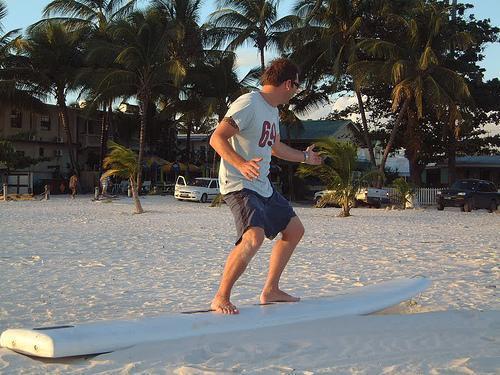How many men are on the surfboard?
Give a very brief answer. 1. 